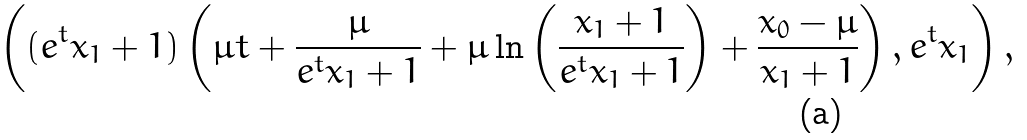<formula> <loc_0><loc_0><loc_500><loc_500>\left ( ( e ^ { t } x _ { 1 } + 1 ) \left ( \mu t + \frac { \mu } { e ^ { t } x _ { 1 } + 1 } + \mu \ln \left ( \frac { x _ { 1 } + 1 } { e ^ { t } x _ { 1 } + 1 } \right ) + \frac { x _ { 0 } - \mu } { x _ { 1 } + 1 } \right ) , e ^ { t } x _ { 1 } \right ) ,</formula> 